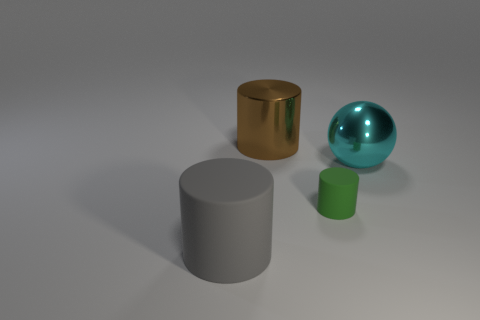Add 4 small blue balls. How many objects exist? 8 Subtract all cylinders. How many objects are left? 1 Add 3 small green rubber objects. How many small green rubber objects exist? 4 Subtract 0 brown balls. How many objects are left? 4 Subtract all shiny balls. Subtract all large yellow things. How many objects are left? 3 Add 4 big brown things. How many big brown things are left? 5 